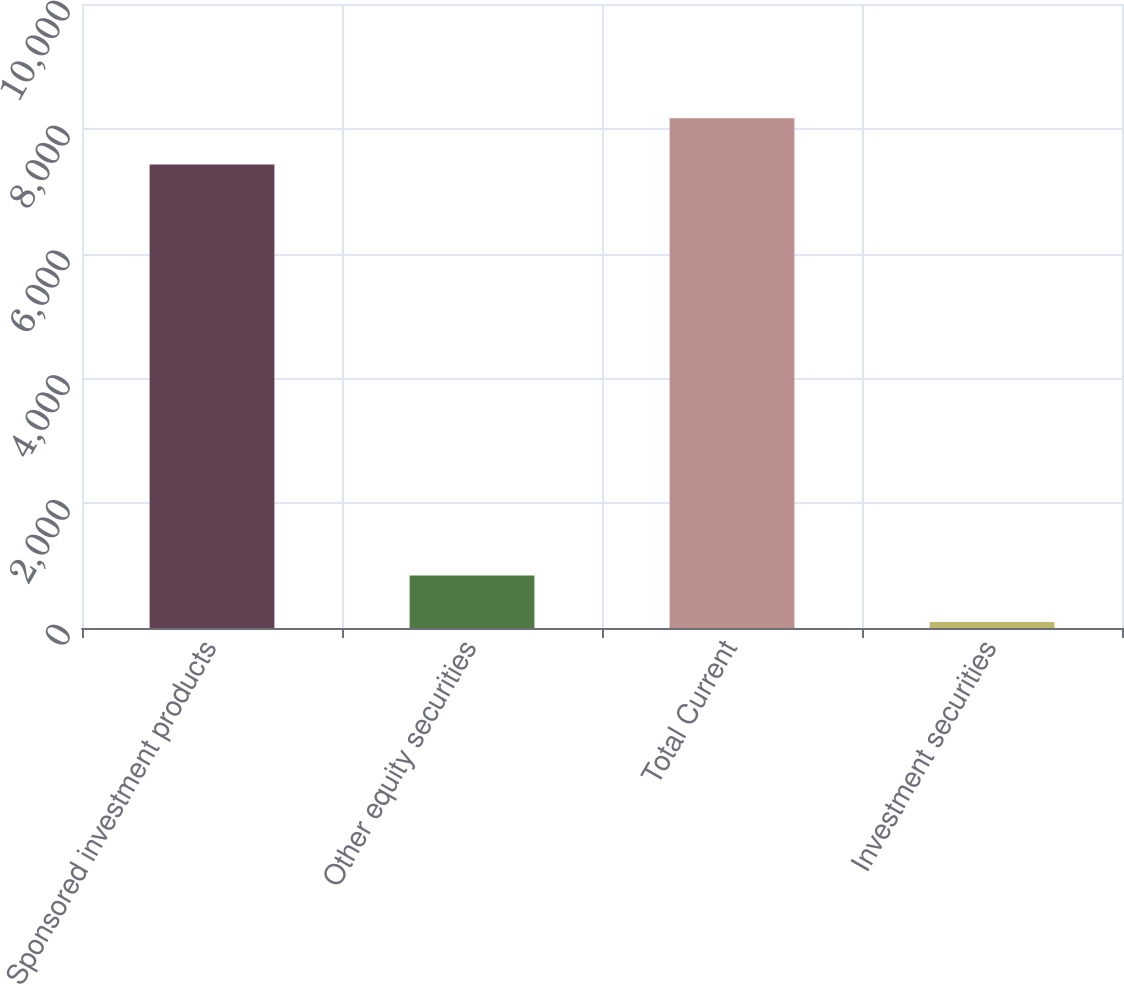Convert chart to OTSL. <chart><loc_0><loc_0><loc_500><loc_500><bar_chart><fcel>Sponsored investment products<fcel>Other equity securities<fcel>Total Current<fcel>Investment securities<nl><fcel>7426<fcel>841.9<fcel>8169.9<fcel>98<nl></chart> 